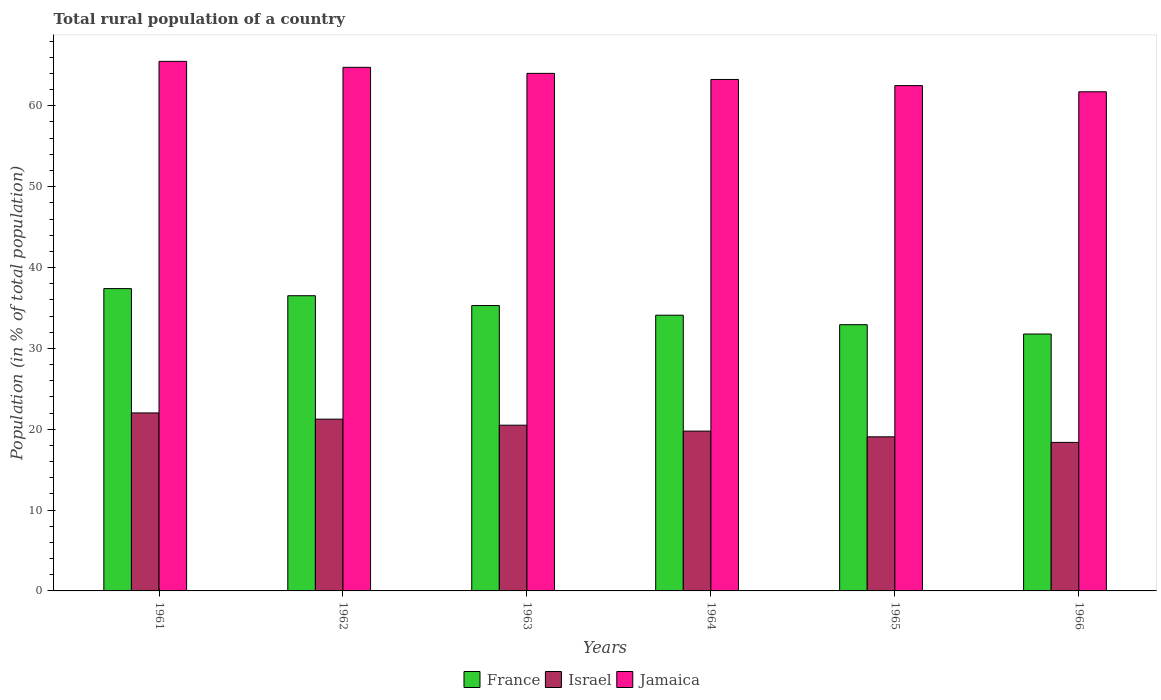How many different coloured bars are there?
Make the answer very short. 3. How many groups of bars are there?
Ensure brevity in your answer.  6. Are the number of bars per tick equal to the number of legend labels?
Your answer should be very brief. Yes. How many bars are there on the 3rd tick from the right?
Your answer should be very brief. 3. What is the label of the 1st group of bars from the left?
Keep it short and to the point. 1961. What is the rural population in France in 1966?
Provide a short and direct response. 31.77. Across all years, what is the maximum rural population in Jamaica?
Give a very brief answer. 65.5. Across all years, what is the minimum rural population in Israel?
Offer a very short reply. 18.37. In which year was the rural population in Israel minimum?
Your answer should be very brief. 1966. What is the total rural population in France in the graph?
Offer a very short reply. 208.01. What is the difference between the rural population in Jamaica in 1963 and that in 1964?
Offer a terse response. 0.76. What is the difference between the rural population in France in 1962 and the rural population in Israel in 1963?
Keep it short and to the point. 16.01. What is the average rural population in Israel per year?
Offer a very short reply. 20.16. In the year 1965, what is the difference between the rural population in Israel and rural population in France?
Keep it short and to the point. -13.87. In how many years, is the rural population in Jamaica greater than 58 %?
Ensure brevity in your answer.  6. What is the ratio of the rural population in France in 1963 to that in 1964?
Offer a terse response. 1.04. Is the difference between the rural population in Israel in 1962 and 1963 greater than the difference between the rural population in France in 1962 and 1963?
Keep it short and to the point. No. What is the difference between the highest and the second highest rural population in France?
Your response must be concise. 0.88. What is the difference between the highest and the lowest rural population in France?
Your answer should be compact. 5.62. In how many years, is the rural population in Israel greater than the average rural population in Israel taken over all years?
Keep it short and to the point. 3. What does the 1st bar from the left in 1966 represents?
Give a very brief answer. France. What does the 3rd bar from the right in 1961 represents?
Keep it short and to the point. France. How many bars are there?
Your response must be concise. 18. How many years are there in the graph?
Give a very brief answer. 6. Are the values on the major ticks of Y-axis written in scientific E-notation?
Offer a terse response. No. Does the graph contain any zero values?
Offer a very short reply. No. How many legend labels are there?
Provide a succinct answer. 3. How are the legend labels stacked?
Provide a short and direct response. Horizontal. What is the title of the graph?
Give a very brief answer. Total rural population of a country. What is the label or title of the X-axis?
Your answer should be compact. Years. What is the label or title of the Y-axis?
Make the answer very short. Population (in % of total population). What is the Population (in % of total population) in France in 1961?
Provide a succinct answer. 37.39. What is the Population (in % of total population) in Israel in 1961?
Your response must be concise. 22.02. What is the Population (in % of total population) in Jamaica in 1961?
Your response must be concise. 65.5. What is the Population (in % of total population) of France in 1962?
Provide a short and direct response. 36.51. What is the Population (in % of total population) in Israel in 1962?
Your response must be concise. 21.25. What is the Population (in % of total population) of Jamaica in 1962?
Offer a terse response. 64.76. What is the Population (in % of total population) of France in 1963?
Your response must be concise. 35.3. What is the Population (in % of total population) in Israel in 1963?
Offer a very short reply. 20.5. What is the Population (in % of total population) of Jamaica in 1963?
Ensure brevity in your answer.  64.02. What is the Population (in % of total population) of France in 1964?
Your answer should be very brief. 34.1. What is the Population (in % of total population) of Israel in 1964?
Give a very brief answer. 19.77. What is the Population (in % of total population) in Jamaica in 1964?
Give a very brief answer. 63.26. What is the Population (in % of total population) in France in 1965?
Provide a succinct answer. 32.93. What is the Population (in % of total population) in Israel in 1965?
Provide a short and direct response. 19.06. What is the Population (in % of total population) in Jamaica in 1965?
Give a very brief answer. 62.5. What is the Population (in % of total population) of France in 1966?
Your answer should be compact. 31.77. What is the Population (in % of total population) in Israel in 1966?
Your answer should be compact. 18.37. What is the Population (in % of total population) of Jamaica in 1966?
Ensure brevity in your answer.  61.73. Across all years, what is the maximum Population (in % of total population) in France?
Provide a succinct answer. 37.39. Across all years, what is the maximum Population (in % of total population) of Israel?
Provide a succinct answer. 22.02. Across all years, what is the maximum Population (in % of total population) of Jamaica?
Give a very brief answer. 65.5. Across all years, what is the minimum Population (in % of total population) of France?
Your answer should be very brief. 31.77. Across all years, what is the minimum Population (in % of total population) in Israel?
Make the answer very short. 18.37. Across all years, what is the minimum Population (in % of total population) in Jamaica?
Offer a very short reply. 61.73. What is the total Population (in % of total population) of France in the graph?
Your answer should be compact. 208.01. What is the total Population (in % of total population) of Israel in the graph?
Offer a terse response. 120.96. What is the total Population (in % of total population) in Jamaica in the graph?
Give a very brief answer. 381.77. What is the difference between the Population (in % of total population) in France in 1961 and that in 1962?
Give a very brief answer. 0.88. What is the difference between the Population (in % of total population) in Israel in 1961 and that in 1962?
Ensure brevity in your answer.  0.77. What is the difference between the Population (in % of total population) of Jamaica in 1961 and that in 1962?
Offer a very short reply. 0.74. What is the difference between the Population (in % of total population) in France in 1961 and that in 1963?
Your answer should be compact. 2.1. What is the difference between the Population (in % of total population) in Israel in 1961 and that in 1963?
Offer a terse response. 1.52. What is the difference between the Population (in % of total population) in Jamaica in 1961 and that in 1963?
Your answer should be very brief. 1.49. What is the difference between the Population (in % of total population) of France in 1961 and that in 1964?
Provide a succinct answer. 3.29. What is the difference between the Population (in % of total population) in Israel in 1961 and that in 1964?
Give a very brief answer. 2.25. What is the difference between the Population (in % of total population) of Jamaica in 1961 and that in 1964?
Provide a succinct answer. 2.24. What is the difference between the Population (in % of total population) of France in 1961 and that in 1965?
Keep it short and to the point. 4.46. What is the difference between the Population (in % of total population) of Israel in 1961 and that in 1965?
Give a very brief answer. 2.96. What is the difference between the Population (in % of total population) of Jamaica in 1961 and that in 1965?
Provide a short and direct response. 3. What is the difference between the Population (in % of total population) of France in 1961 and that in 1966?
Keep it short and to the point. 5.62. What is the difference between the Population (in % of total population) of Israel in 1961 and that in 1966?
Your answer should be very brief. 3.65. What is the difference between the Population (in % of total population) in Jamaica in 1961 and that in 1966?
Make the answer very short. 3.77. What is the difference between the Population (in % of total population) of France in 1962 and that in 1963?
Your answer should be very brief. 1.21. What is the difference between the Population (in % of total population) in Israel in 1962 and that in 1963?
Make the answer very short. 0.75. What is the difference between the Population (in % of total population) of Jamaica in 1962 and that in 1963?
Your answer should be very brief. 0.75. What is the difference between the Population (in % of total population) of France in 1962 and that in 1964?
Your answer should be compact. 2.41. What is the difference between the Population (in % of total population) in Israel in 1962 and that in 1964?
Ensure brevity in your answer.  1.48. What is the difference between the Population (in % of total population) in Jamaica in 1962 and that in 1964?
Ensure brevity in your answer.  1.5. What is the difference between the Population (in % of total population) in France in 1962 and that in 1965?
Offer a very short reply. 3.58. What is the difference between the Population (in % of total population) of Israel in 1962 and that in 1965?
Give a very brief answer. 2.19. What is the difference between the Population (in % of total population) in Jamaica in 1962 and that in 1965?
Provide a short and direct response. 2.26. What is the difference between the Population (in % of total population) of France in 1962 and that in 1966?
Offer a very short reply. 4.74. What is the difference between the Population (in % of total population) of Israel in 1962 and that in 1966?
Keep it short and to the point. 2.88. What is the difference between the Population (in % of total population) of Jamaica in 1962 and that in 1966?
Your response must be concise. 3.03. What is the difference between the Population (in % of total population) of France in 1963 and that in 1964?
Give a very brief answer. 1.2. What is the difference between the Population (in % of total population) in Israel in 1963 and that in 1964?
Offer a terse response. 0.73. What is the difference between the Population (in % of total population) of Jamaica in 1963 and that in 1964?
Give a very brief answer. 0.76. What is the difference between the Population (in % of total population) of France in 1963 and that in 1965?
Ensure brevity in your answer.  2.37. What is the difference between the Population (in % of total population) in Israel in 1963 and that in 1965?
Provide a short and direct response. 1.44. What is the difference between the Population (in % of total population) in Jamaica in 1963 and that in 1965?
Offer a terse response. 1.51. What is the difference between the Population (in % of total population) of France in 1963 and that in 1966?
Provide a short and direct response. 3.52. What is the difference between the Population (in % of total population) of Israel in 1963 and that in 1966?
Give a very brief answer. 2.13. What is the difference between the Population (in % of total population) in Jamaica in 1963 and that in 1966?
Make the answer very short. 2.28. What is the difference between the Population (in % of total population) in France in 1964 and that in 1965?
Provide a succinct answer. 1.17. What is the difference between the Population (in % of total population) of Israel in 1964 and that in 1965?
Offer a terse response. 0.71. What is the difference between the Population (in % of total population) of Jamaica in 1964 and that in 1965?
Ensure brevity in your answer.  0.76. What is the difference between the Population (in % of total population) of France in 1964 and that in 1966?
Your response must be concise. 2.33. What is the difference between the Population (in % of total population) of Israel in 1964 and that in 1966?
Make the answer very short. 1.4. What is the difference between the Population (in % of total population) of Jamaica in 1964 and that in 1966?
Offer a terse response. 1.52. What is the difference between the Population (in % of total population) in France in 1965 and that in 1966?
Your answer should be very brief. 1.15. What is the difference between the Population (in % of total population) in Israel in 1965 and that in 1966?
Give a very brief answer. 0.69. What is the difference between the Population (in % of total population) in Jamaica in 1965 and that in 1966?
Provide a short and direct response. 0.77. What is the difference between the Population (in % of total population) in France in 1961 and the Population (in % of total population) in Israel in 1962?
Offer a very short reply. 16.15. What is the difference between the Population (in % of total population) in France in 1961 and the Population (in % of total population) in Jamaica in 1962?
Provide a succinct answer. -27.37. What is the difference between the Population (in % of total population) in Israel in 1961 and the Population (in % of total population) in Jamaica in 1962?
Keep it short and to the point. -42.75. What is the difference between the Population (in % of total population) of France in 1961 and the Population (in % of total population) of Israel in 1963?
Offer a very short reply. 16.89. What is the difference between the Population (in % of total population) in France in 1961 and the Population (in % of total population) in Jamaica in 1963?
Offer a very short reply. -26.62. What is the difference between the Population (in % of total population) in Israel in 1961 and the Population (in % of total population) in Jamaica in 1963?
Provide a succinct answer. -42. What is the difference between the Population (in % of total population) of France in 1961 and the Population (in % of total population) of Israel in 1964?
Your answer should be very brief. 17.62. What is the difference between the Population (in % of total population) in France in 1961 and the Population (in % of total population) in Jamaica in 1964?
Ensure brevity in your answer.  -25.87. What is the difference between the Population (in % of total population) in Israel in 1961 and the Population (in % of total population) in Jamaica in 1964?
Keep it short and to the point. -41.24. What is the difference between the Population (in % of total population) in France in 1961 and the Population (in % of total population) in Israel in 1965?
Provide a succinct answer. 18.33. What is the difference between the Population (in % of total population) of France in 1961 and the Population (in % of total population) of Jamaica in 1965?
Your answer should be compact. -25.11. What is the difference between the Population (in % of total population) of Israel in 1961 and the Population (in % of total population) of Jamaica in 1965?
Ensure brevity in your answer.  -40.49. What is the difference between the Population (in % of total population) of France in 1961 and the Population (in % of total population) of Israel in 1966?
Provide a succinct answer. 19.02. What is the difference between the Population (in % of total population) of France in 1961 and the Population (in % of total population) of Jamaica in 1966?
Your answer should be compact. -24.34. What is the difference between the Population (in % of total population) in Israel in 1961 and the Population (in % of total population) in Jamaica in 1966?
Provide a short and direct response. -39.72. What is the difference between the Population (in % of total population) in France in 1962 and the Population (in % of total population) in Israel in 1963?
Offer a very short reply. 16.01. What is the difference between the Population (in % of total population) in France in 1962 and the Population (in % of total population) in Jamaica in 1963?
Your response must be concise. -27.5. What is the difference between the Population (in % of total population) of Israel in 1962 and the Population (in % of total population) of Jamaica in 1963?
Offer a terse response. -42.77. What is the difference between the Population (in % of total population) in France in 1962 and the Population (in % of total population) in Israel in 1964?
Provide a succinct answer. 16.74. What is the difference between the Population (in % of total population) of France in 1962 and the Population (in % of total population) of Jamaica in 1964?
Provide a short and direct response. -26.75. What is the difference between the Population (in % of total population) in Israel in 1962 and the Population (in % of total population) in Jamaica in 1964?
Your answer should be very brief. -42.01. What is the difference between the Population (in % of total population) of France in 1962 and the Population (in % of total population) of Israel in 1965?
Make the answer very short. 17.45. What is the difference between the Population (in % of total population) in France in 1962 and the Population (in % of total population) in Jamaica in 1965?
Provide a short and direct response. -25.99. What is the difference between the Population (in % of total population) of Israel in 1962 and the Population (in % of total population) of Jamaica in 1965?
Your answer should be compact. -41.26. What is the difference between the Population (in % of total population) of France in 1962 and the Population (in % of total population) of Israel in 1966?
Keep it short and to the point. 18.14. What is the difference between the Population (in % of total population) of France in 1962 and the Population (in % of total population) of Jamaica in 1966?
Make the answer very short. -25.22. What is the difference between the Population (in % of total population) in Israel in 1962 and the Population (in % of total population) in Jamaica in 1966?
Provide a short and direct response. -40.49. What is the difference between the Population (in % of total population) in France in 1963 and the Population (in % of total population) in Israel in 1964?
Ensure brevity in your answer.  15.53. What is the difference between the Population (in % of total population) of France in 1963 and the Population (in % of total population) of Jamaica in 1964?
Offer a very short reply. -27.96. What is the difference between the Population (in % of total population) of Israel in 1963 and the Population (in % of total population) of Jamaica in 1964?
Keep it short and to the point. -42.76. What is the difference between the Population (in % of total population) of France in 1963 and the Population (in % of total population) of Israel in 1965?
Give a very brief answer. 16.24. What is the difference between the Population (in % of total population) of France in 1963 and the Population (in % of total population) of Jamaica in 1965?
Your response must be concise. -27.2. What is the difference between the Population (in % of total population) in Israel in 1963 and the Population (in % of total population) in Jamaica in 1965?
Your answer should be compact. -42. What is the difference between the Population (in % of total population) of France in 1963 and the Population (in % of total population) of Israel in 1966?
Your response must be concise. 16.93. What is the difference between the Population (in % of total population) of France in 1963 and the Population (in % of total population) of Jamaica in 1966?
Your answer should be compact. -26.44. What is the difference between the Population (in % of total population) in Israel in 1963 and the Population (in % of total population) in Jamaica in 1966?
Make the answer very short. -41.24. What is the difference between the Population (in % of total population) of France in 1964 and the Population (in % of total population) of Israel in 1965?
Your answer should be very brief. 15.04. What is the difference between the Population (in % of total population) of France in 1964 and the Population (in % of total population) of Jamaica in 1965?
Your answer should be compact. -28.4. What is the difference between the Population (in % of total population) in Israel in 1964 and the Population (in % of total population) in Jamaica in 1965?
Ensure brevity in your answer.  -42.73. What is the difference between the Population (in % of total population) in France in 1964 and the Population (in % of total population) in Israel in 1966?
Offer a terse response. 15.73. What is the difference between the Population (in % of total population) in France in 1964 and the Population (in % of total population) in Jamaica in 1966?
Offer a very short reply. -27.63. What is the difference between the Population (in % of total population) of Israel in 1964 and the Population (in % of total population) of Jamaica in 1966?
Ensure brevity in your answer.  -41.97. What is the difference between the Population (in % of total population) of France in 1965 and the Population (in % of total population) of Israel in 1966?
Ensure brevity in your answer.  14.56. What is the difference between the Population (in % of total population) in France in 1965 and the Population (in % of total population) in Jamaica in 1966?
Keep it short and to the point. -28.81. What is the difference between the Population (in % of total population) in Israel in 1965 and the Population (in % of total population) in Jamaica in 1966?
Your answer should be compact. -42.67. What is the average Population (in % of total population) of France per year?
Make the answer very short. 34.67. What is the average Population (in % of total population) in Israel per year?
Provide a succinct answer. 20.16. What is the average Population (in % of total population) in Jamaica per year?
Provide a short and direct response. 63.63. In the year 1961, what is the difference between the Population (in % of total population) in France and Population (in % of total population) in Israel?
Keep it short and to the point. 15.38. In the year 1961, what is the difference between the Population (in % of total population) in France and Population (in % of total population) in Jamaica?
Your answer should be compact. -28.11. In the year 1961, what is the difference between the Population (in % of total population) in Israel and Population (in % of total population) in Jamaica?
Your response must be concise. -43.48. In the year 1962, what is the difference between the Population (in % of total population) of France and Population (in % of total population) of Israel?
Your answer should be very brief. 15.27. In the year 1962, what is the difference between the Population (in % of total population) in France and Population (in % of total population) in Jamaica?
Make the answer very short. -28.25. In the year 1962, what is the difference between the Population (in % of total population) of Israel and Population (in % of total population) of Jamaica?
Make the answer very short. -43.52. In the year 1963, what is the difference between the Population (in % of total population) of France and Population (in % of total population) of Israel?
Give a very brief answer. 14.8. In the year 1963, what is the difference between the Population (in % of total population) of France and Population (in % of total population) of Jamaica?
Ensure brevity in your answer.  -28.72. In the year 1963, what is the difference between the Population (in % of total population) of Israel and Population (in % of total population) of Jamaica?
Your answer should be compact. -43.52. In the year 1964, what is the difference between the Population (in % of total population) in France and Population (in % of total population) in Israel?
Your answer should be compact. 14.33. In the year 1964, what is the difference between the Population (in % of total population) of France and Population (in % of total population) of Jamaica?
Your answer should be compact. -29.16. In the year 1964, what is the difference between the Population (in % of total population) of Israel and Population (in % of total population) of Jamaica?
Provide a succinct answer. -43.49. In the year 1965, what is the difference between the Population (in % of total population) in France and Population (in % of total population) in Israel?
Ensure brevity in your answer.  13.87. In the year 1965, what is the difference between the Population (in % of total population) in France and Population (in % of total population) in Jamaica?
Your response must be concise. -29.57. In the year 1965, what is the difference between the Population (in % of total population) in Israel and Population (in % of total population) in Jamaica?
Provide a succinct answer. -43.44. In the year 1966, what is the difference between the Population (in % of total population) of France and Population (in % of total population) of Israel?
Your response must be concise. 13.4. In the year 1966, what is the difference between the Population (in % of total population) of France and Population (in % of total population) of Jamaica?
Keep it short and to the point. -29.96. In the year 1966, what is the difference between the Population (in % of total population) of Israel and Population (in % of total population) of Jamaica?
Offer a terse response. -43.37. What is the ratio of the Population (in % of total population) in France in 1961 to that in 1962?
Your answer should be very brief. 1.02. What is the ratio of the Population (in % of total population) in Israel in 1961 to that in 1962?
Offer a very short reply. 1.04. What is the ratio of the Population (in % of total population) in Jamaica in 1961 to that in 1962?
Your answer should be compact. 1.01. What is the ratio of the Population (in % of total population) of France in 1961 to that in 1963?
Provide a succinct answer. 1.06. What is the ratio of the Population (in % of total population) in Israel in 1961 to that in 1963?
Ensure brevity in your answer.  1.07. What is the ratio of the Population (in % of total population) of Jamaica in 1961 to that in 1963?
Offer a very short reply. 1.02. What is the ratio of the Population (in % of total population) in France in 1961 to that in 1964?
Your response must be concise. 1.1. What is the ratio of the Population (in % of total population) in Israel in 1961 to that in 1964?
Keep it short and to the point. 1.11. What is the ratio of the Population (in % of total population) of Jamaica in 1961 to that in 1964?
Keep it short and to the point. 1.04. What is the ratio of the Population (in % of total population) in France in 1961 to that in 1965?
Provide a short and direct response. 1.14. What is the ratio of the Population (in % of total population) in Israel in 1961 to that in 1965?
Provide a short and direct response. 1.16. What is the ratio of the Population (in % of total population) of Jamaica in 1961 to that in 1965?
Give a very brief answer. 1.05. What is the ratio of the Population (in % of total population) of France in 1961 to that in 1966?
Provide a short and direct response. 1.18. What is the ratio of the Population (in % of total population) of Israel in 1961 to that in 1966?
Provide a succinct answer. 1.2. What is the ratio of the Population (in % of total population) of Jamaica in 1961 to that in 1966?
Give a very brief answer. 1.06. What is the ratio of the Population (in % of total population) in France in 1962 to that in 1963?
Offer a terse response. 1.03. What is the ratio of the Population (in % of total population) of Israel in 1962 to that in 1963?
Your answer should be compact. 1.04. What is the ratio of the Population (in % of total population) of Jamaica in 1962 to that in 1963?
Offer a very short reply. 1.01. What is the ratio of the Population (in % of total population) of France in 1962 to that in 1964?
Provide a short and direct response. 1.07. What is the ratio of the Population (in % of total population) in Israel in 1962 to that in 1964?
Ensure brevity in your answer.  1.07. What is the ratio of the Population (in % of total population) of Jamaica in 1962 to that in 1964?
Your response must be concise. 1.02. What is the ratio of the Population (in % of total population) of France in 1962 to that in 1965?
Your response must be concise. 1.11. What is the ratio of the Population (in % of total population) of Israel in 1962 to that in 1965?
Keep it short and to the point. 1.11. What is the ratio of the Population (in % of total population) in Jamaica in 1962 to that in 1965?
Ensure brevity in your answer.  1.04. What is the ratio of the Population (in % of total population) of France in 1962 to that in 1966?
Give a very brief answer. 1.15. What is the ratio of the Population (in % of total population) in Israel in 1962 to that in 1966?
Provide a succinct answer. 1.16. What is the ratio of the Population (in % of total population) in Jamaica in 1962 to that in 1966?
Ensure brevity in your answer.  1.05. What is the ratio of the Population (in % of total population) of France in 1963 to that in 1964?
Offer a terse response. 1.04. What is the ratio of the Population (in % of total population) in Israel in 1963 to that in 1964?
Your answer should be compact. 1.04. What is the ratio of the Population (in % of total population) in Jamaica in 1963 to that in 1964?
Give a very brief answer. 1.01. What is the ratio of the Population (in % of total population) of France in 1963 to that in 1965?
Provide a short and direct response. 1.07. What is the ratio of the Population (in % of total population) in Israel in 1963 to that in 1965?
Your answer should be compact. 1.08. What is the ratio of the Population (in % of total population) in Jamaica in 1963 to that in 1965?
Offer a very short reply. 1.02. What is the ratio of the Population (in % of total population) in France in 1963 to that in 1966?
Make the answer very short. 1.11. What is the ratio of the Population (in % of total population) in Israel in 1963 to that in 1966?
Offer a terse response. 1.12. What is the ratio of the Population (in % of total population) in Jamaica in 1963 to that in 1966?
Your response must be concise. 1.04. What is the ratio of the Population (in % of total population) of France in 1964 to that in 1965?
Offer a terse response. 1.04. What is the ratio of the Population (in % of total population) of Israel in 1964 to that in 1965?
Ensure brevity in your answer.  1.04. What is the ratio of the Population (in % of total population) in Jamaica in 1964 to that in 1965?
Provide a succinct answer. 1.01. What is the ratio of the Population (in % of total population) in France in 1964 to that in 1966?
Make the answer very short. 1.07. What is the ratio of the Population (in % of total population) in Israel in 1964 to that in 1966?
Your answer should be very brief. 1.08. What is the ratio of the Population (in % of total population) of Jamaica in 1964 to that in 1966?
Your response must be concise. 1.02. What is the ratio of the Population (in % of total population) of France in 1965 to that in 1966?
Your answer should be compact. 1.04. What is the ratio of the Population (in % of total population) of Israel in 1965 to that in 1966?
Your answer should be very brief. 1.04. What is the ratio of the Population (in % of total population) in Jamaica in 1965 to that in 1966?
Keep it short and to the point. 1.01. What is the difference between the highest and the second highest Population (in % of total population) of France?
Your answer should be very brief. 0.88. What is the difference between the highest and the second highest Population (in % of total population) of Israel?
Keep it short and to the point. 0.77. What is the difference between the highest and the second highest Population (in % of total population) in Jamaica?
Your answer should be compact. 0.74. What is the difference between the highest and the lowest Population (in % of total population) in France?
Your answer should be compact. 5.62. What is the difference between the highest and the lowest Population (in % of total population) of Israel?
Your answer should be very brief. 3.65. What is the difference between the highest and the lowest Population (in % of total population) in Jamaica?
Provide a short and direct response. 3.77. 